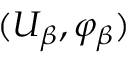Convert formula to latex. <formula><loc_0><loc_0><loc_500><loc_500>( U _ { \beta } , \varphi _ { \beta } )</formula> 